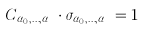Convert formula to latex. <formula><loc_0><loc_0><loc_500><loc_500>C _ { \alpha _ { 0 } , \dots , \alpha _ { p } } \cdot \sigma _ { \alpha _ { 0 } , \dots , \alpha _ { p } } = 1</formula> 